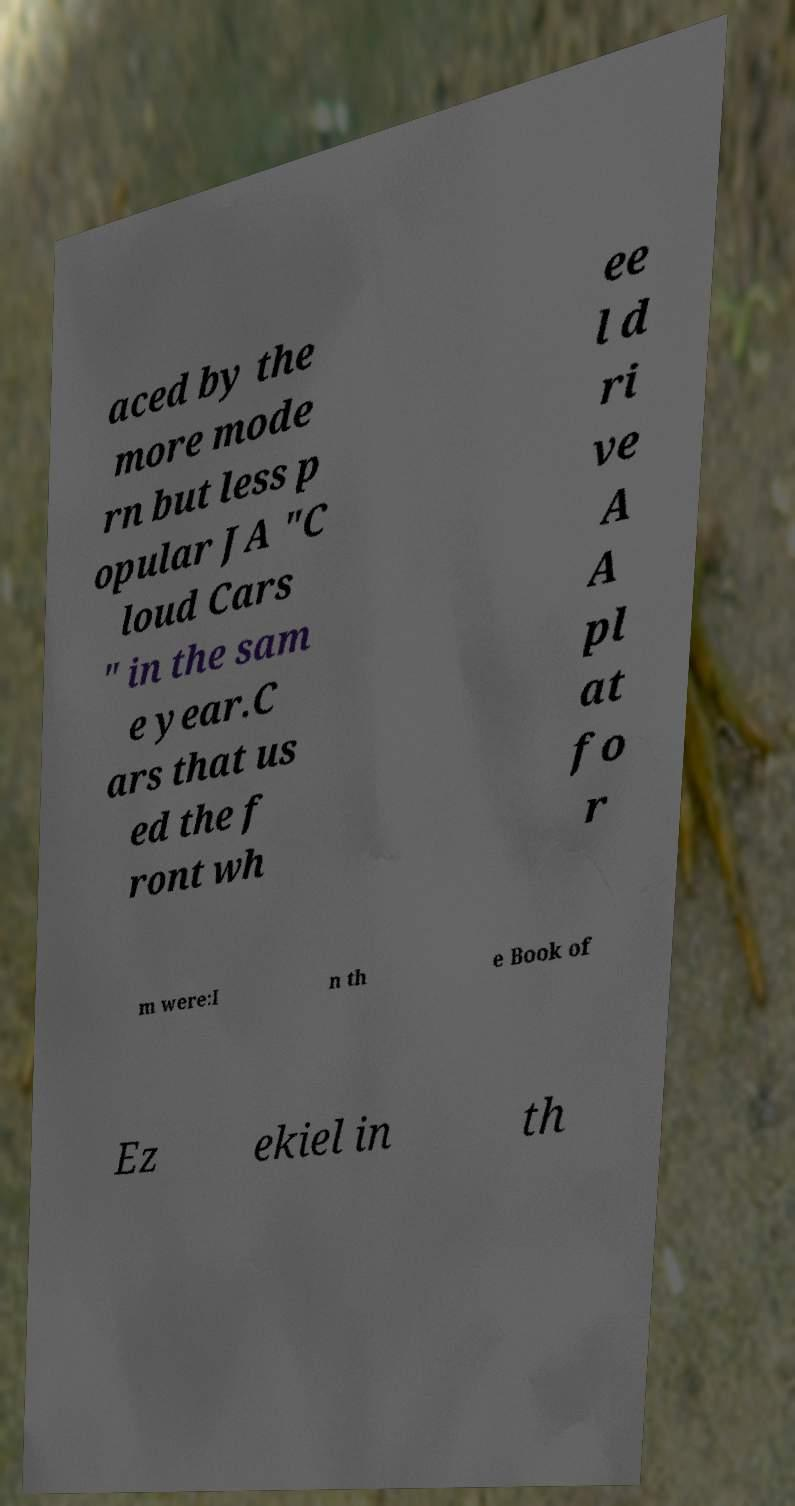Please identify and transcribe the text found in this image. aced by the more mode rn but less p opular JA "C loud Cars " in the sam e year.C ars that us ed the f ront wh ee l d ri ve A A pl at fo r m were:I n th e Book of Ez ekiel in th 